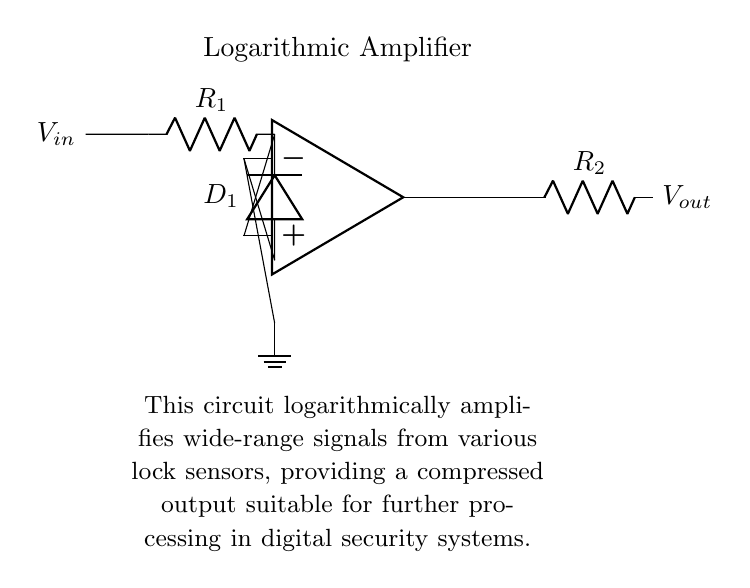What type of amplifier is shown in the circuit? The circuit is labeled as a logarithmic amplifier, indicating its specific function is to generate an output that is logarithmically proportional to the input signal.
Answer: logarithmic amplifier What is connected to the input of the op-amp? The input of the op-amp is connected to a resistor labeled R1, which serves as the first component in the voltage signal path.
Answer: resistor R1 How many resistors are present in the circuit? There are two resistors shown in the circuit: one labeled R1 and the other labeled R2, indicating they are part of the signal processing path.
Answer: two What component provides feedback in this circuit? The feedback is provided by the diode labeled D1, which ensures the op-amp's output is appropriately adjusted for the logarithmic function.
Answer: diode D1 What is the output of this circuit? The output, labeled as Vout, can be found at the terminal connected after the resistor R2, signifying the processed signal output from the amplifier.
Answer: Vout What is the role of the diode in this logarithmic amplifier circuit? The diode D1 is crucial for determining the logarithmic relationship by allowing current to flow in one direction while restricting it, thus producing a logarithmic output based on the input voltage level.
Answer: establishes logarithmic relationship Where does the ground connect in this circuit? The ground connects to the negative terminal of the op-amp, which stabilizes the circuit and provides a reference point for all voltage levels in the configuration.
Answer: to the op-amp negative terminal 